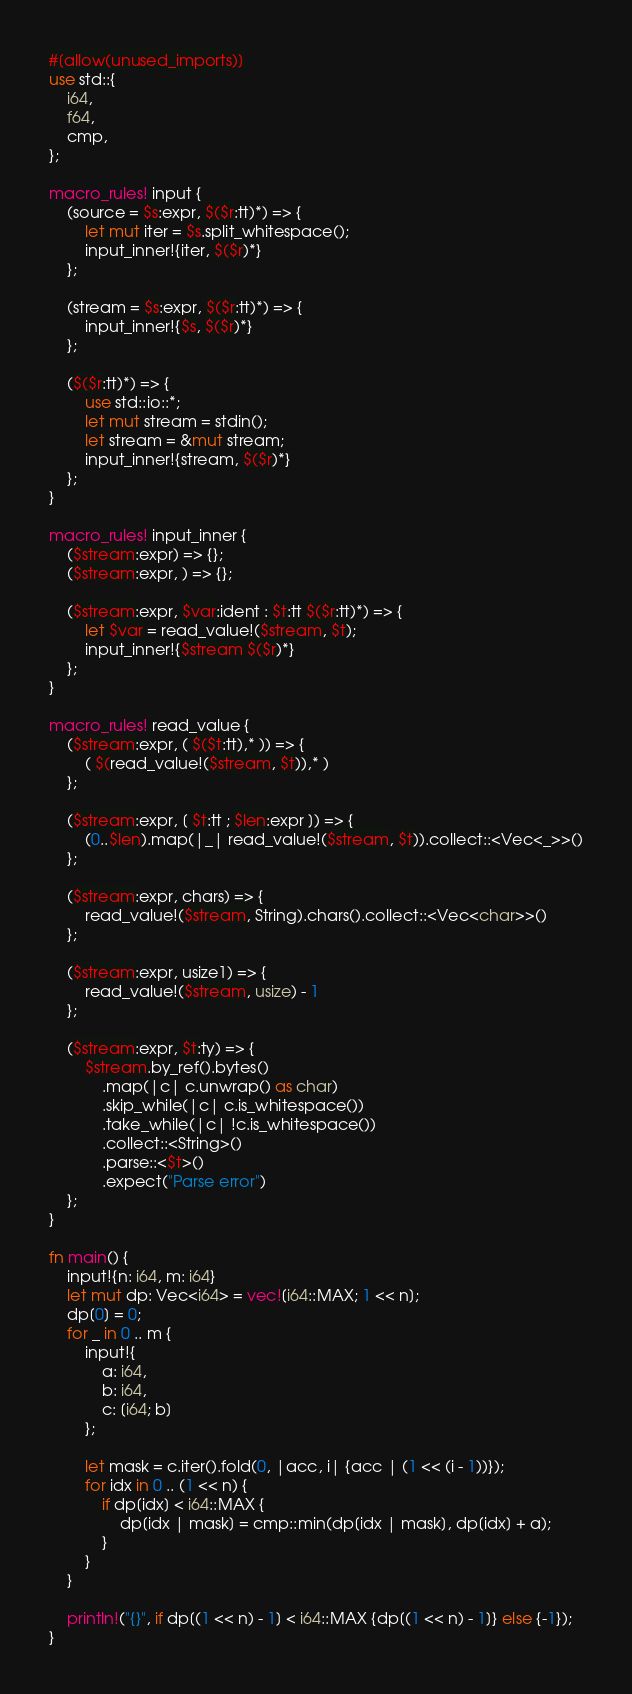<code> <loc_0><loc_0><loc_500><loc_500><_Rust_>#[allow(unused_imports)]
use std::{
    i64,
    f64,
    cmp,
};

macro_rules! input {
    (source = $s:expr, $($r:tt)*) => {
        let mut iter = $s.split_whitespace();
        input_inner!{iter, $($r)*}
    };

    (stream = $s:expr, $($r:tt)*) => {
        input_inner!{$s, $($r)*}
    };

    ($($r:tt)*) => {
        use std::io::*;
        let mut stream = stdin();
        let stream = &mut stream;
        input_inner!{stream, $($r)*}
    };
}

macro_rules! input_inner {
    ($stream:expr) => {};
    ($stream:expr, ) => {};

    ($stream:expr, $var:ident : $t:tt $($r:tt)*) => {
        let $var = read_value!($stream, $t);
        input_inner!{$stream $($r)*}
    };
}

macro_rules! read_value {
    ($stream:expr, ( $($t:tt),* )) => {
        ( $(read_value!($stream, $t)),* )
    };

    ($stream:expr, [ $t:tt ; $len:expr ]) => {
        (0..$len).map(|_| read_value!($stream, $t)).collect::<Vec<_>>()
    };

    ($stream:expr, chars) => {
        read_value!($stream, String).chars().collect::<Vec<char>>()
    };

    ($stream:expr, usize1) => {
        read_value!($stream, usize) - 1
    };

    ($stream:expr, $t:ty) => {
        $stream.by_ref().bytes()
            .map(|c| c.unwrap() as char)
            .skip_while(|c| c.is_whitespace())
            .take_while(|c| !c.is_whitespace())
            .collect::<String>()
            .parse::<$t>()
            .expect("Parse error")
    };
}

fn main() {
    input!{n: i64, m: i64}
    let mut dp: Vec<i64> = vec![i64::MAX; 1 << n];
    dp[0] = 0;
    for _ in 0 .. m {
        input!{
            a: i64,
            b: i64,
            c: [i64; b]
        };

        let mask = c.iter().fold(0, |acc, i| {acc | (1 << (i - 1))});
        for idx in 0 .. (1 << n) {
            if dp[idx] < i64::MAX {
                dp[idx | mask] = cmp::min(dp[idx | mask], dp[idx] + a);
            }
        }
    }

    println!("{}", if dp[(1 << n) - 1] < i64::MAX {dp[(1 << n) - 1]} else {-1});
}</code> 